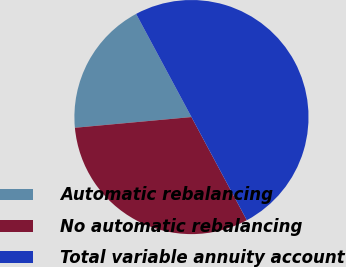<chart> <loc_0><loc_0><loc_500><loc_500><pie_chart><fcel>Automatic rebalancing<fcel>No automatic rebalancing<fcel>Total variable annuity account<nl><fcel>18.62%<fcel>31.38%<fcel>50.0%<nl></chart> 